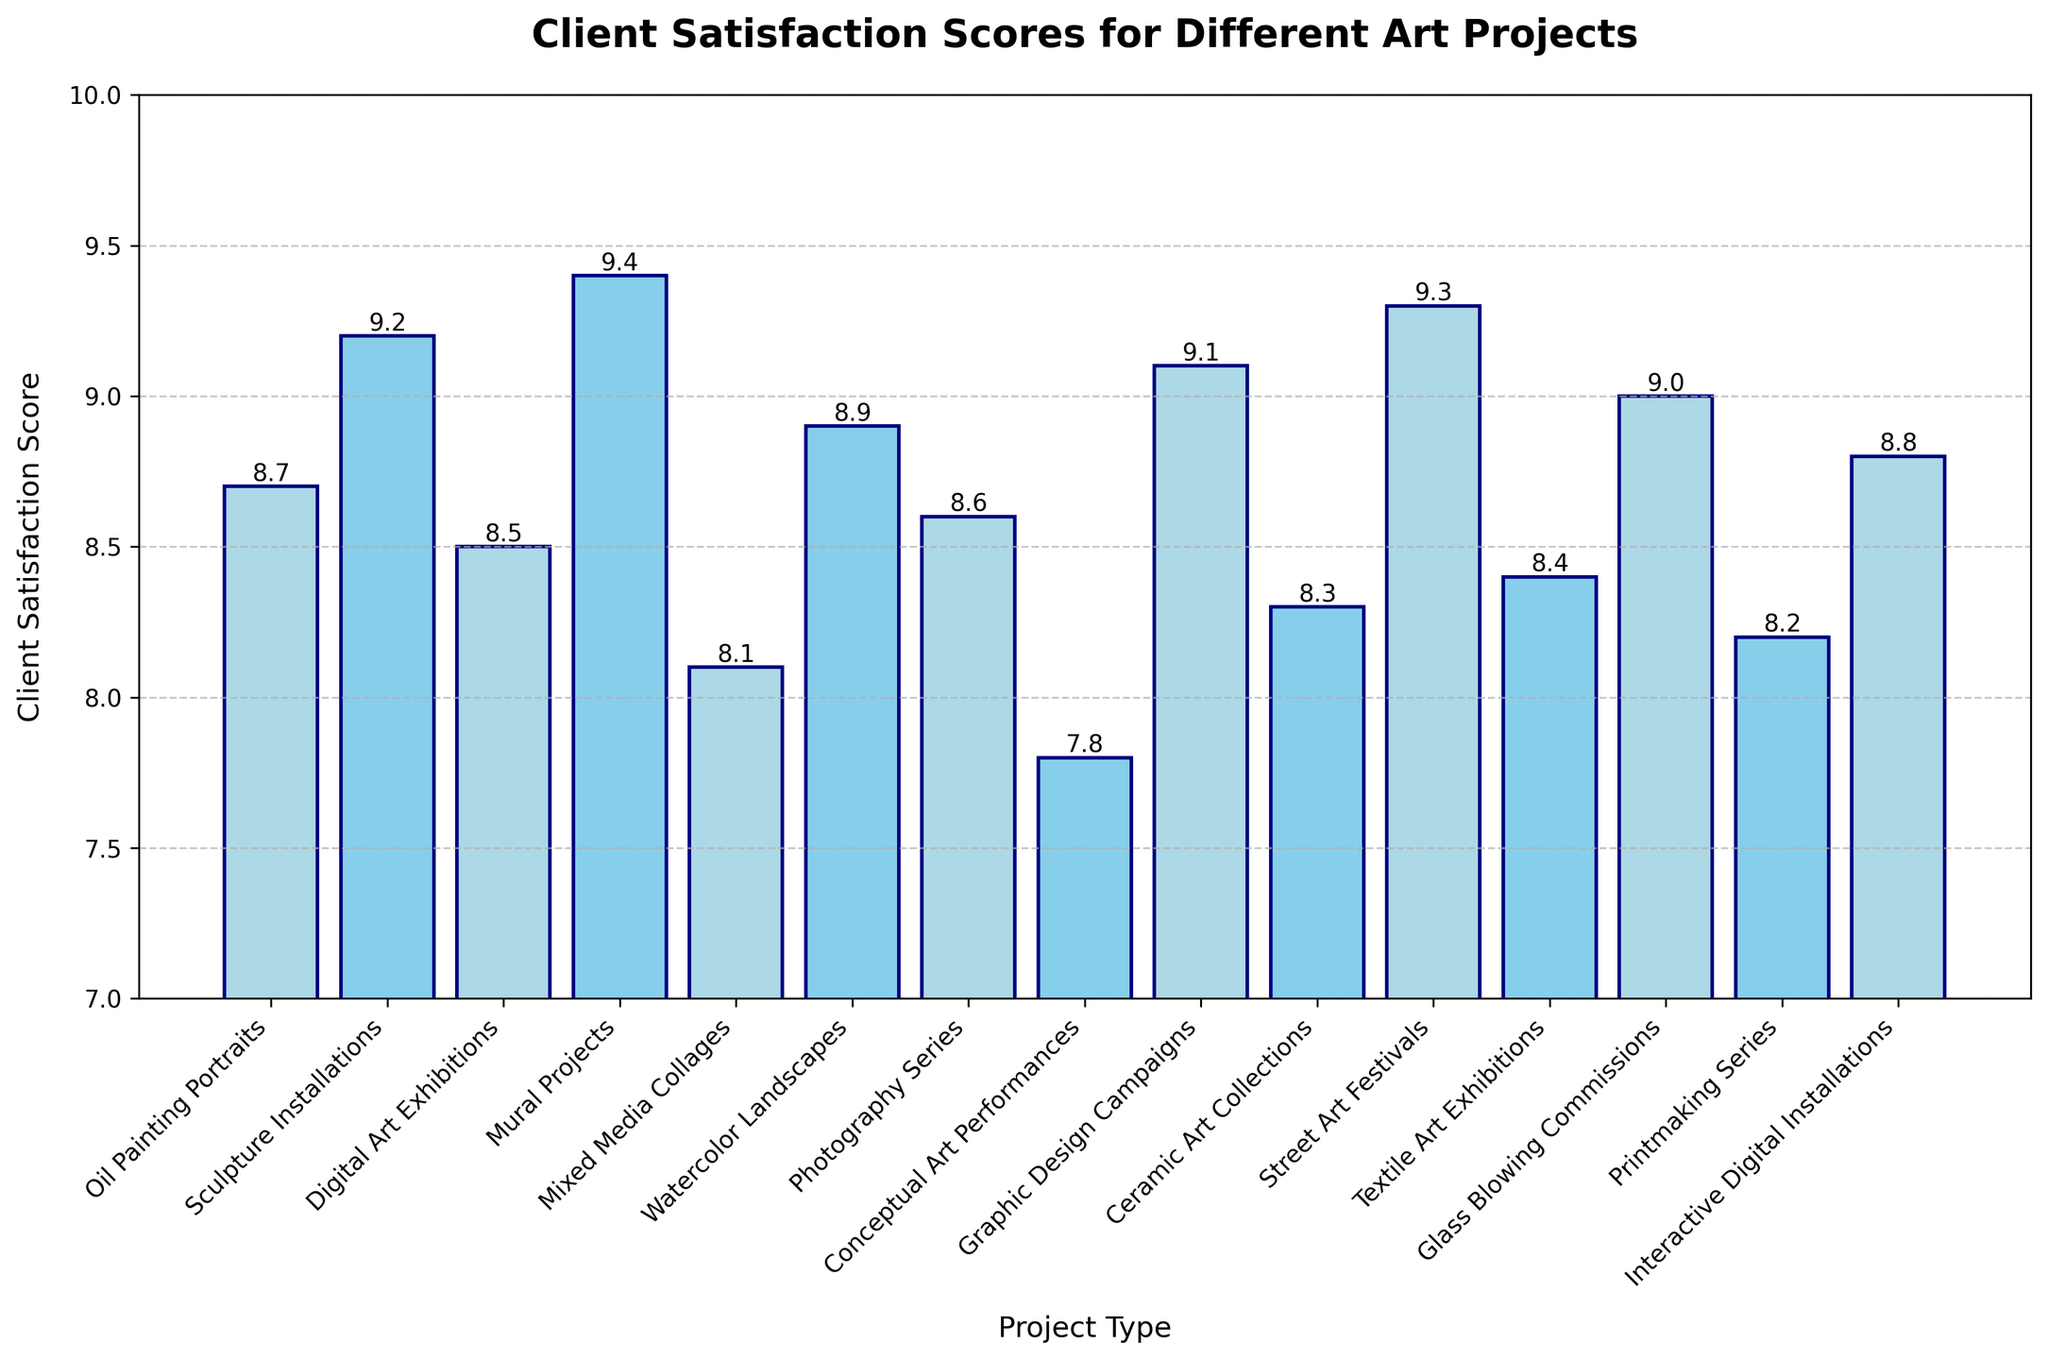Which project type has the highest client satisfaction score? To find the answer, look at the highest bar in the chart. The tallest bar corresponds to the project type 'Mural Projects' with a score of 9.4.
Answer: Mural Projects What is the range of client satisfaction scores? The range is calculated by subtracting the lowest score from the highest score. The lowest score is 7.8 (Conceptual Art Performances) and the highest score is 9.4 (Mural Projects), so the range is 9.4 - 7.8.
Answer: 1.6 How many project types have a client satisfaction score above 9.0? Look at the bars that go above the 9.0 mark. These are 'Sculpture Installations,' 'Mural Projects,' 'Graphic Design Campaigns,' 'Street Art Festivals,' and 'Glass Blowing Commissions,' totaling 5.
Answer: 5 What is the difference in client satisfaction scores between 'Oil Painting Portraits' and 'Conceptual Art Performances'? Find the scores for both project types. Oil Painting Portraits has a score of 8.7 and Conceptual Art Performances has a score of 7.8. The difference is 8.7 - 7.8.
Answer: 0.9 Are there more project types with scores above 8.0 or below 8.0? Count the number of bars with heights above 8.0 (14) and compare with those below 8.0 (0). Since all scores are above 8.0, there are more project types above 8.0.
Answer: Above 8.0 Which two project types have the closest client satisfaction scores? Compare the scores of all project types to find the smallest difference. 'Photography Series' (8.6) and 'Textile Art Exhibitions' (8.4) have a difference of 0.2.
Answer: Photography Series and Textile Art Exhibitions What's the average client satisfaction score for all project types? Add all the scores together and divide by the number of project types (15). The sum of the scores is 130.
Answer: 8.7 What color are the bars for 'Conceptual Art Performances' and 'Interactive Digital Installations'? Determine the color based on the pattern described (alternate bars colored). The first bar is 'lightblue,' so 'Conceptual Art Performances' (8th bar) is 'lightblue' and 'Interactive Digital Installations' (15th bar) is 'skyblue'.
Answer: lightblue and skyblue 